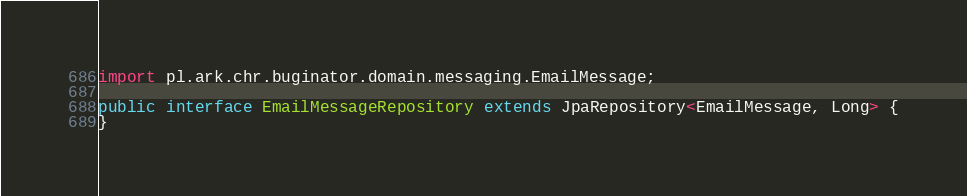<code> <loc_0><loc_0><loc_500><loc_500><_Java_>import pl.ark.chr.buginator.domain.messaging.EmailMessage;

public interface EmailMessageRepository extends JpaRepository<EmailMessage, Long> {
}
</code> 